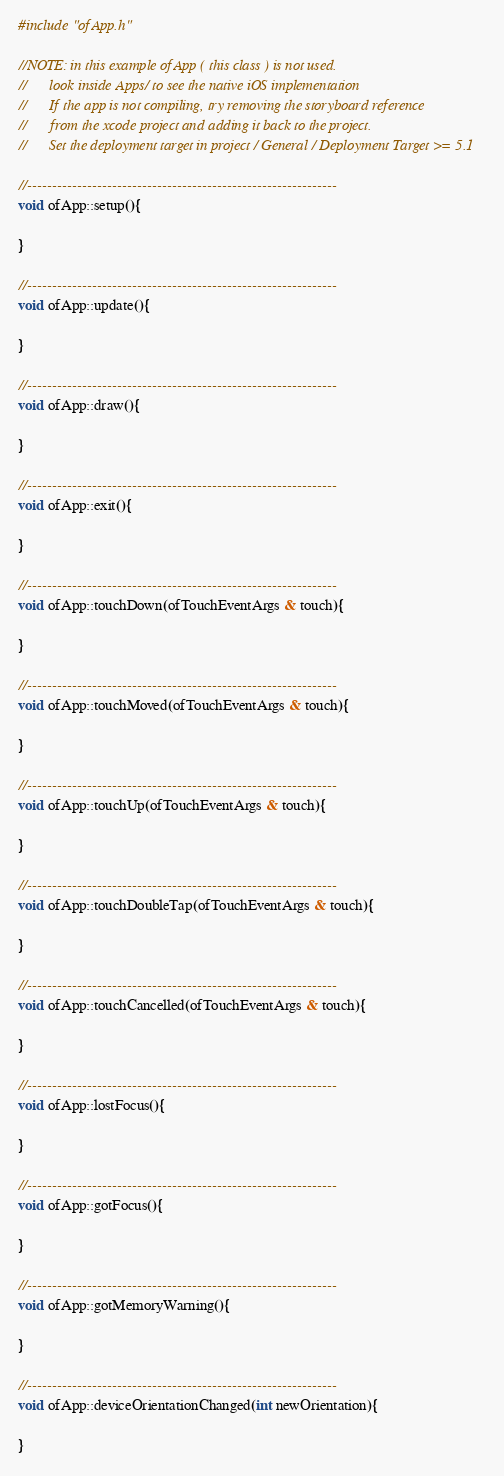<code> <loc_0><loc_0><loc_500><loc_500><_ObjectiveC_>#include "ofApp.h"

//NOTE: in this example ofApp ( this class ) is not used. 
//      look inside Apps/ to see the native iOS implementation
//      If the app is not compiling, try removing the storyboard reference
//      from the xcode project and adding it back to the project.
//      Set the deployment target in project / General / Deployment Target >= 5.1

//--------------------------------------------------------------
void ofApp::setup(){	
    
}

//--------------------------------------------------------------
void ofApp::update(){

}

//--------------------------------------------------------------
void ofApp::draw(){
	
}

//--------------------------------------------------------------
void ofApp::exit(){

}

//--------------------------------------------------------------
void ofApp::touchDown(ofTouchEventArgs & touch){

}

//--------------------------------------------------------------
void ofApp::touchMoved(ofTouchEventArgs & touch){

}

//--------------------------------------------------------------
void ofApp::touchUp(ofTouchEventArgs & touch){

}

//--------------------------------------------------------------
void ofApp::touchDoubleTap(ofTouchEventArgs & touch){

}

//--------------------------------------------------------------
void ofApp::touchCancelled(ofTouchEventArgs & touch){
    
}

//--------------------------------------------------------------
void ofApp::lostFocus(){

}

//--------------------------------------------------------------
void ofApp::gotFocus(){

}

//--------------------------------------------------------------
void ofApp::gotMemoryWarning(){

}

//--------------------------------------------------------------
void ofApp::deviceOrientationChanged(int newOrientation){

}

</code> 